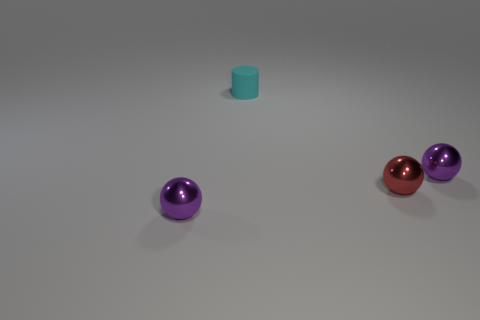There is a tiny metallic sphere on the left side of the small red ball; does it have the same color as the small matte object behind the red metallic object?
Keep it short and to the point. No. Are there more tiny metal objects that are on the right side of the cyan thing than red shiny balls?
Give a very brief answer. Yes. How many other objects are the same color as the matte object?
Your answer should be compact. 0. Do the shiny sphere behind the red shiny ball and the cyan cylinder have the same size?
Your answer should be very brief. Yes. Is there a purple rubber sphere of the same size as the red sphere?
Provide a succinct answer. No. The small ball that is left of the cylinder is what color?
Your answer should be compact. Purple. There is a tiny thing that is both behind the red sphere and to the right of the tiny cyan matte object; what shape is it?
Provide a succinct answer. Sphere. What number of red metallic things are the same shape as the tiny rubber thing?
Your answer should be very brief. 0. How many rubber objects are there?
Offer a very short reply. 1. What is the size of the thing that is both behind the small red metallic ball and right of the cyan matte thing?
Provide a succinct answer. Small. 